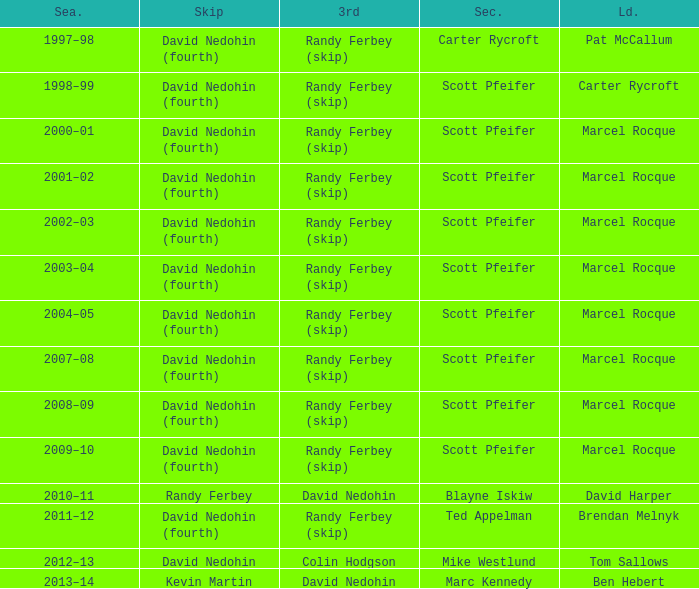Which Second has a Lead of ben hebert? Marc Kennedy. Would you be able to parse every entry in this table? {'header': ['Sea.', 'Skip', '3rd', 'Sec.', 'Ld.'], 'rows': [['1997–98', 'David Nedohin (fourth)', 'Randy Ferbey (skip)', 'Carter Rycroft', 'Pat McCallum'], ['1998–99', 'David Nedohin (fourth)', 'Randy Ferbey (skip)', 'Scott Pfeifer', 'Carter Rycroft'], ['2000–01', 'David Nedohin (fourth)', 'Randy Ferbey (skip)', 'Scott Pfeifer', 'Marcel Rocque'], ['2001–02', 'David Nedohin (fourth)', 'Randy Ferbey (skip)', 'Scott Pfeifer', 'Marcel Rocque'], ['2002–03', 'David Nedohin (fourth)', 'Randy Ferbey (skip)', 'Scott Pfeifer', 'Marcel Rocque'], ['2003–04', 'David Nedohin (fourth)', 'Randy Ferbey (skip)', 'Scott Pfeifer', 'Marcel Rocque'], ['2004–05', 'David Nedohin (fourth)', 'Randy Ferbey (skip)', 'Scott Pfeifer', 'Marcel Rocque'], ['2007–08', 'David Nedohin (fourth)', 'Randy Ferbey (skip)', 'Scott Pfeifer', 'Marcel Rocque'], ['2008–09', 'David Nedohin (fourth)', 'Randy Ferbey (skip)', 'Scott Pfeifer', 'Marcel Rocque'], ['2009–10', 'David Nedohin (fourth)', 'Randy Ferbey (skip)', 'Scott Pfeifer', 'Marcel Rocque'], ['2010–11', 'Randy Ferbey', 'David Nedohin', 'Blayne Iskiw', 'David Harper'], ['2011–12', 'David Nedohin (fourth)', 'Randy Ferbey (skip)', 'Ted Appelman', 'Brendan Melnyk'], ['2012–13', 'David Nedohin', 'Colin Hodgson', 'Mike Westlund', 'Tom Sallows'], ['2013–14', 'Kevin Martin', 'David Nedohin', 'Marc Kennedy', 'Ben Hebert']]} 